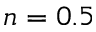<formula> <loc_0><loc_0><loc_500><loc_500>n = 0 . 5</formula> 